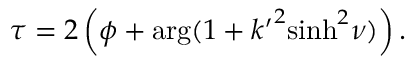Convert formula to latex. <formula><loc_0><loc_0><loc_500><loc_500>\tau = 2 \left ( \phi + \arg ( 1 + { k ^ { \prime } } ^ { 2 } { \sinh } ^ { 2 } \nu ) \right ) .</formula> 